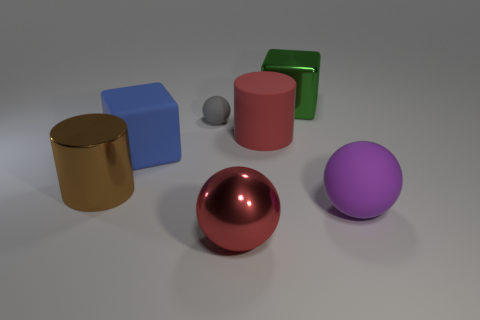Subtract all red metal spheres. How many spheres are left? 2 Add 3 green metallic objects. How many objects exist? 10 Subtract 1 red balls. How many objects are left? 6 Subtract all balls. How many objects are left? 4 Subtract 1 blocks. How many blocks are left? 1 Subtract all cyan spheres. Subtract all blue cubes. How many spheres are left? 3 Subtract all large shiny things. Subtract all green metallic things. How many objects are left? 3 Add 7 small objects. How many small objects are left? 8 Add 3 small gray objects. How many small gray objects exist? 4 Subtract all gray spheres. How many spheres are left? 2 